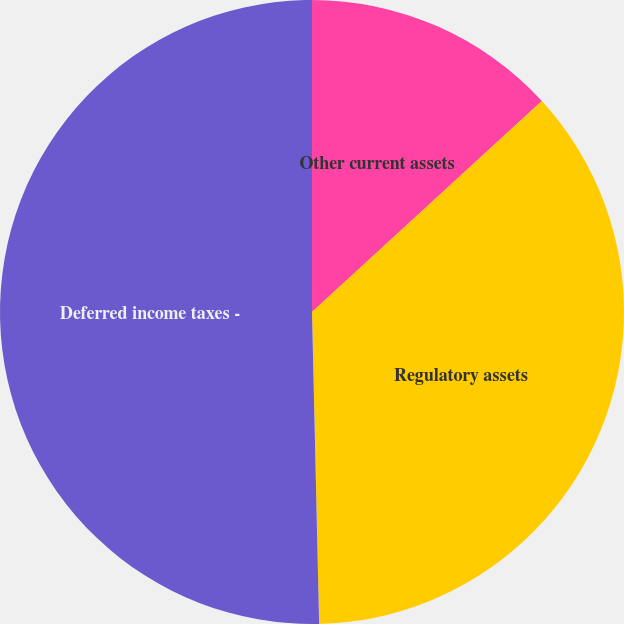Convert chart. <chart><loc_0><loc_0><loc_500><loc_500><pie_chart><fcel>Other current assets<fcel>Regulatory assets<fcel>Deferred income taxes -<nl><fcel>13.18%<fcel>36.45%<fcel>50.36%<nl></chart> 